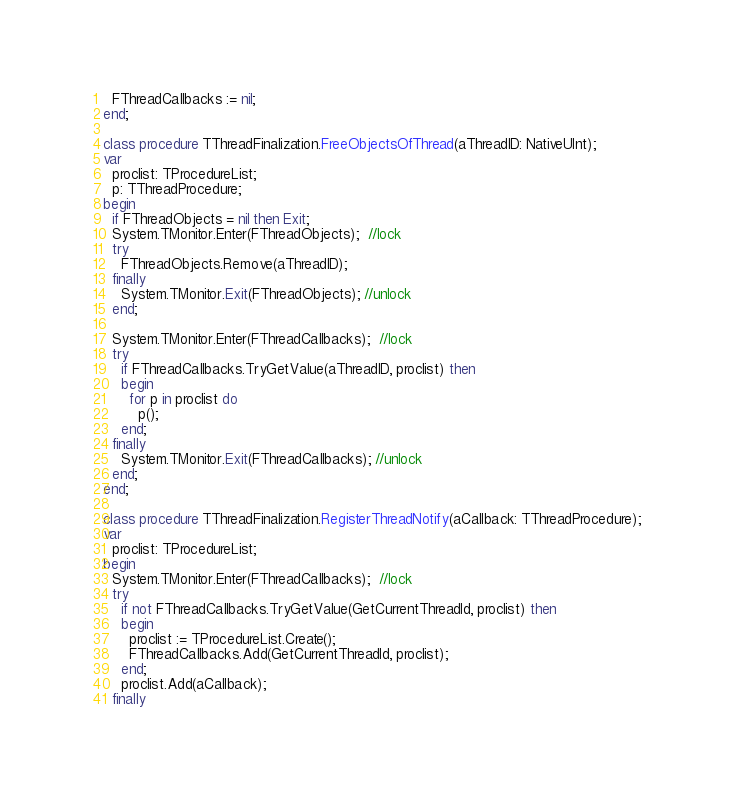Convert code to text. <code><loc_0><loc_0><loc_500><loc_500><_Pascal_>  FThreadCallbacks := nil;
end;

class procedure TThreadFinalization.FreeObjectsOfThread(aThreadID: NativeUInt);
var
  proclist: TProcedureList;
  p: TThreadProcedure;
begin
  if FThreadObjects = nil then Exit;
  System.TMonitor.Enter(FThreadObjects);  //lock
  try
    FThreadObjects.Remove(aThreadID);
  finally
    System.TMonitor.Exit(FThreadObjects); //unlock
  end;

  System.TMonitor.Enter(FThreadCallbacks);  //lock
  try
    if FThreadCallbacks.TryGetValue(aThreadID, proclist) then
    begin
      for p in proclist do
        p();
    end;
  finally
    System.TMonitor.Exit(FThreadCallbacks); //unlock
  end;
end;

class procedure TThreadFinalization.RegisterThreadNotify(aCallback: TThreadProcedure);
var
  proclist: TProcedureList;
begin
  System.TMonitor.Enter(FThreadCallbacks);  //lock
  try
    if not FThreadCallbacks.TryGetValue(GetCurrentThreadId, proclist) then
    begin
      proclist := TProcedureList.Create();
      FThreadCallbacks.Add(GetCurrentThreadId, proclist);
    end;
    proclist.Add(aCallback);
  finally</code> 